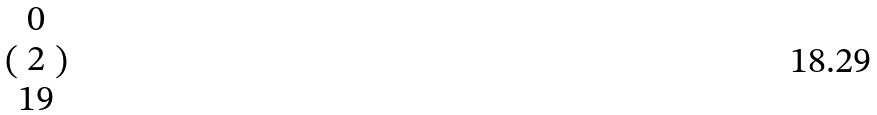<formula> <loc_0><loc_0><loc_500><loc_500>( \begin{matrix} 0 \\ 2 \\ 1 9 \end{matrix} )</formula> 